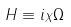Convert formula to latex. <formula><loc_0><loc_0><loc_500><loc_500>H \equiv i _ { X } \Omega</formula> 